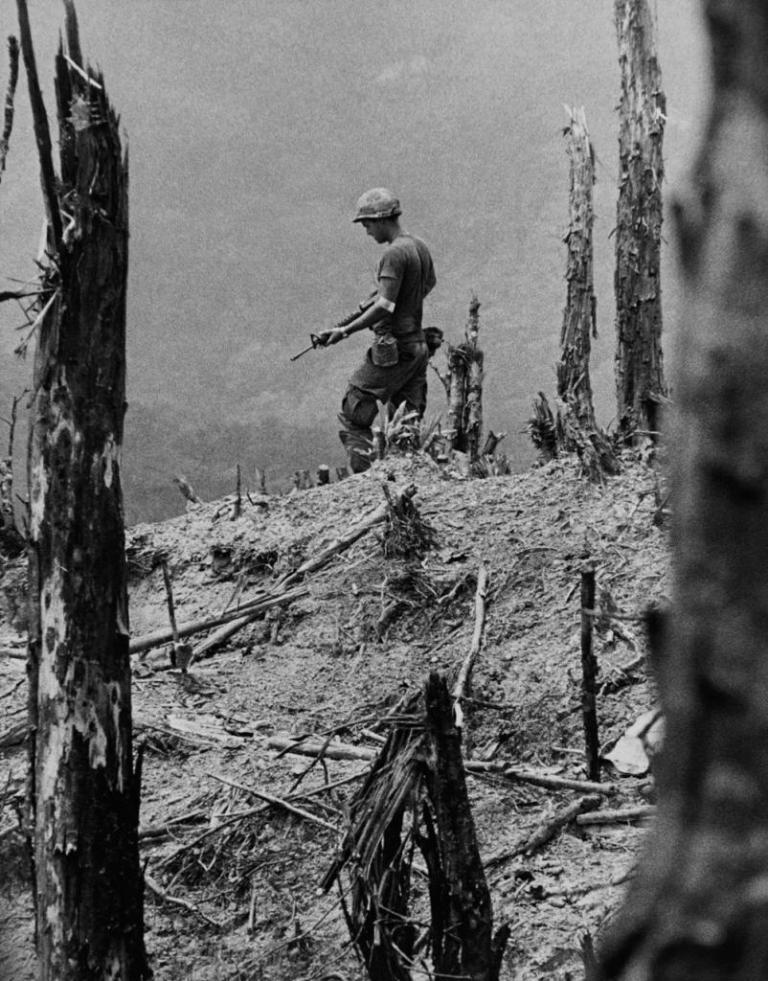What is the color scheme of the image? The image is black and white. What type of objects can be seen in the image? There are logs and dried sticks in the image. Who is present in the image? A man is present in the image. What is the man wearing? The man is wearing a t-shirt, trousers, and a cap. What is the man holding in his hands? The man is holding a weapon in his hands. Can you see a rabbit sitting on the sofa in the image? There is no rabbit or sofa present in the image. What type of gun is the man holding in the image? The facts provided do not specify the type of weapon the man is holding, only that he is holding a weapon. 